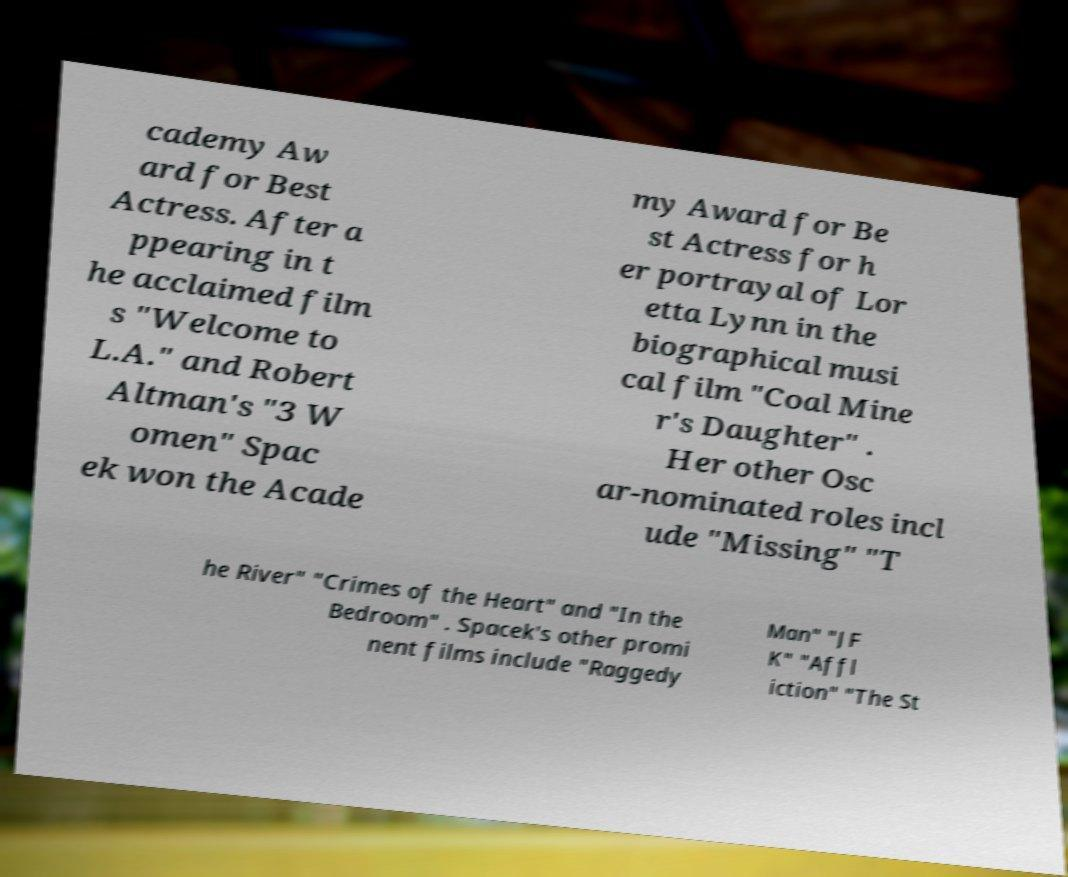Please read and relay the text visible in this image. What does it say? cademy Aw ard for Best Actress. After a ppearing in t he acclaimed film s "Welcome to L.A." and Robert Altman's "3 W omen" Spac ek won the Acade my Award for Be st Actress for h er portrayal of Lor etta Lynn in the biographical musi cal film "Coal Mine r's Daughter" . Her other Osc ar-nominated roles incl ude "Missing" "T he River" "Crimes of the Heart" and "In the Bedroom" . Spacek's other promi nent films include "Raggedy Man" "JF K" "Affl iction" "The St 